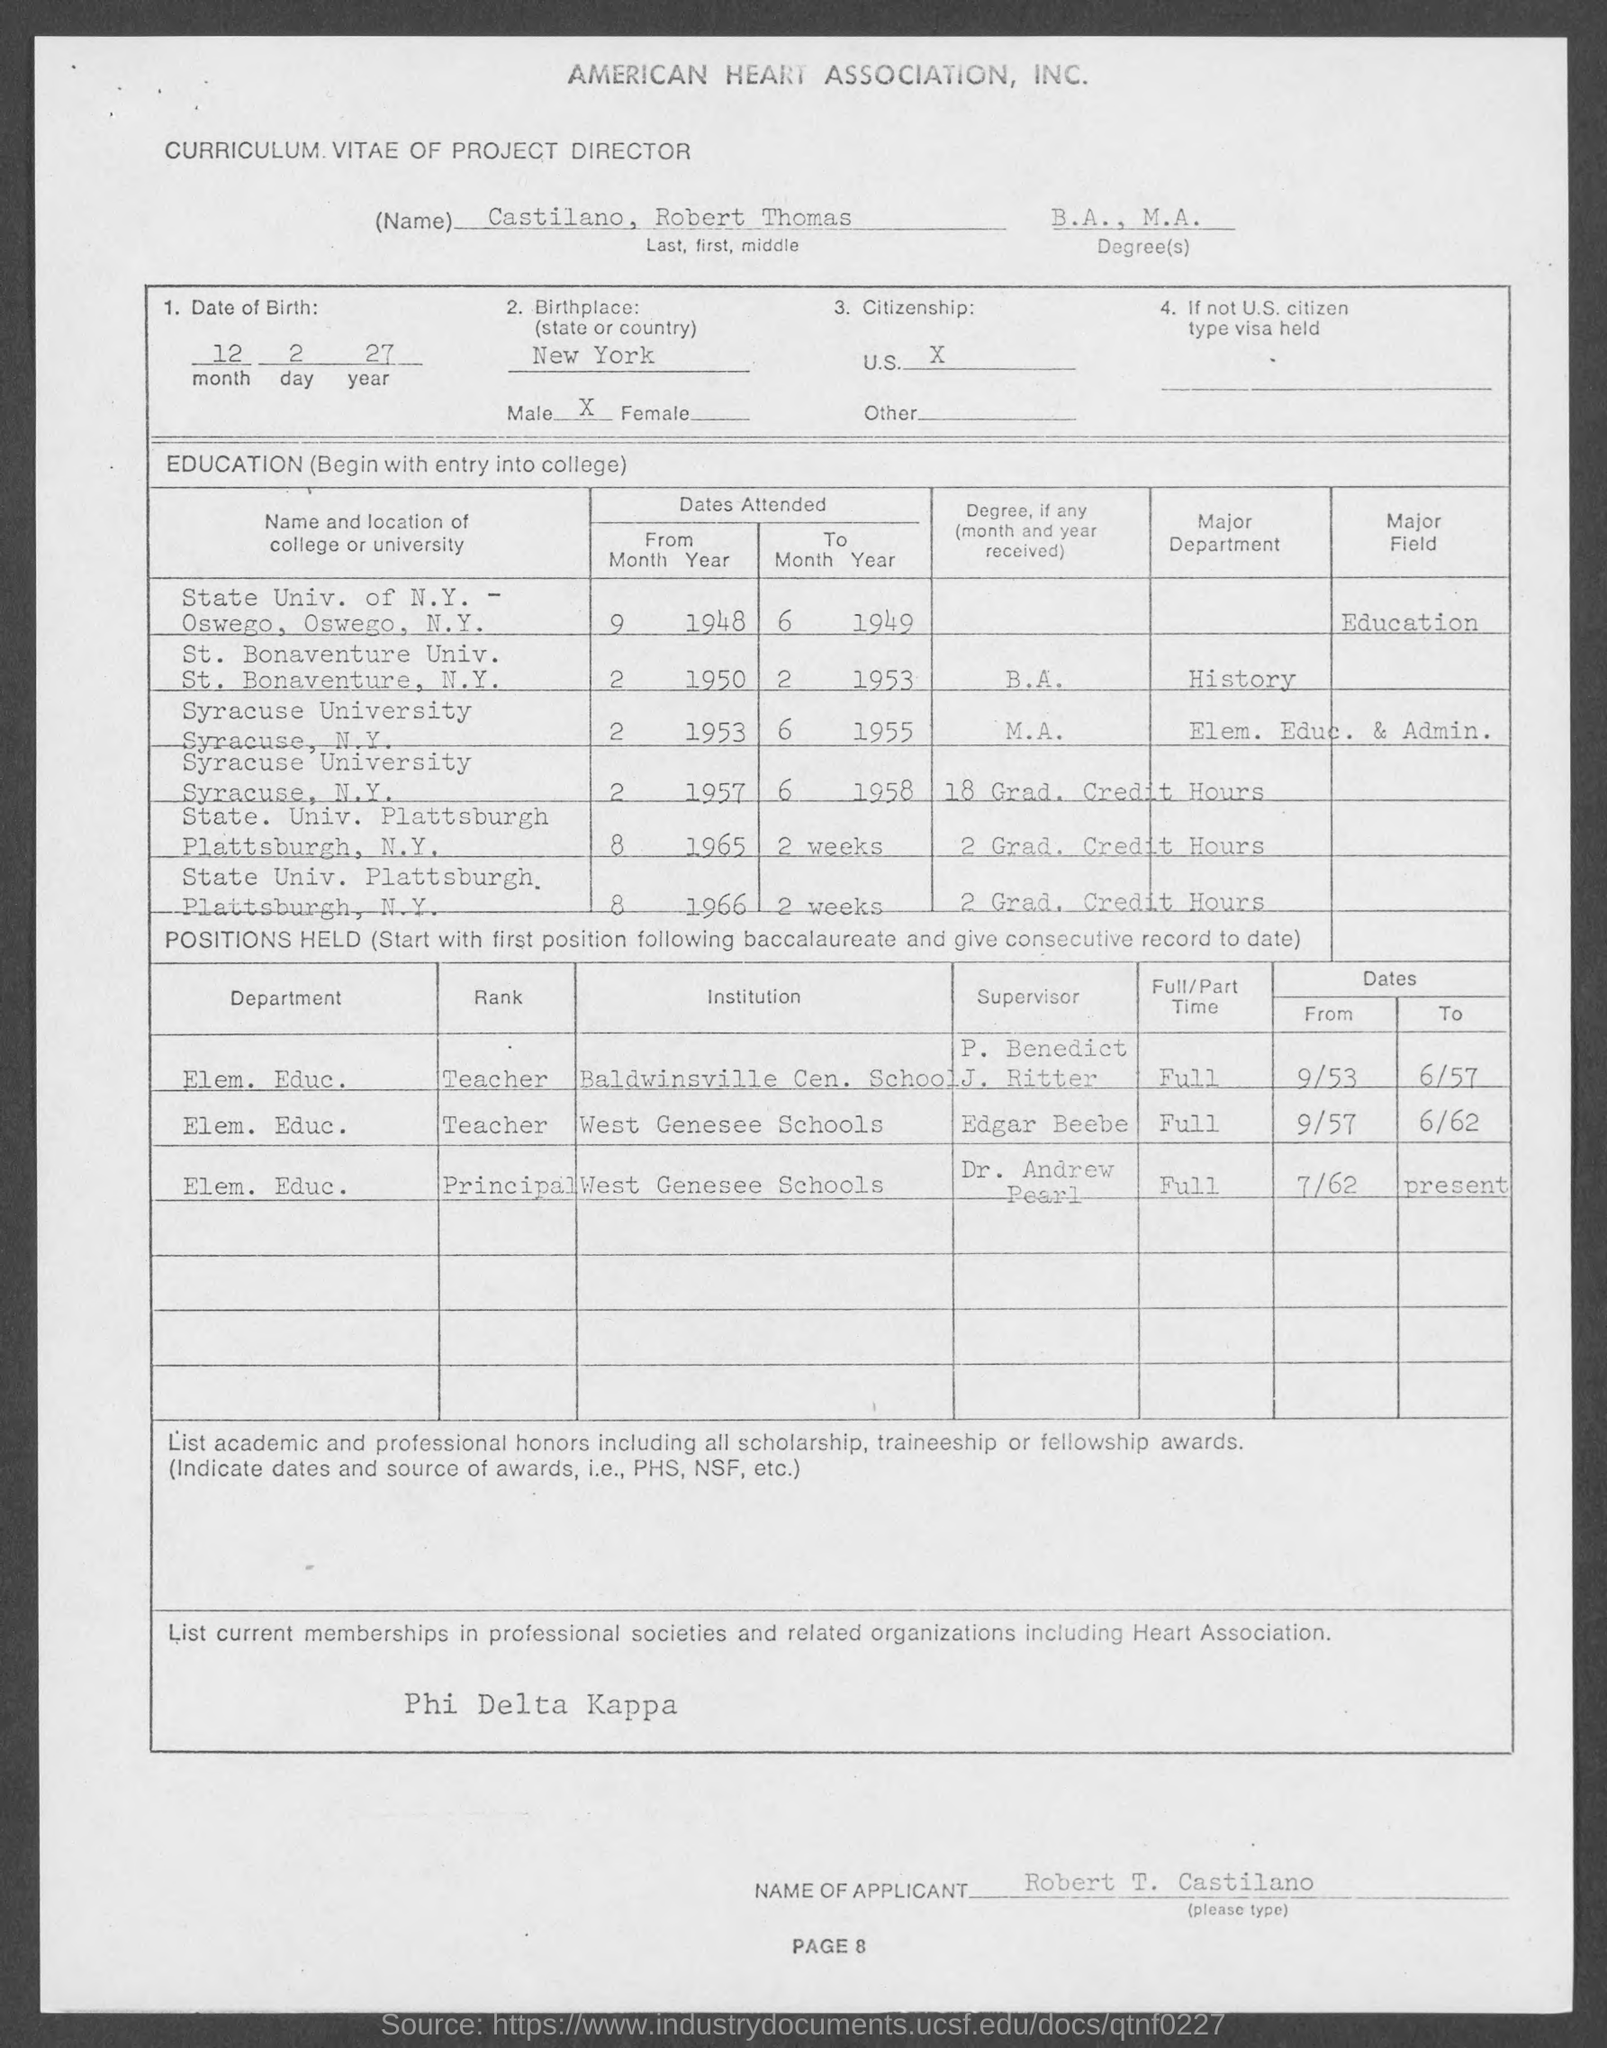What is the Title of the document?
Your answer should be compact. Curriculum Vitae of project Director. What is the Name?
Provide a succinct answer. Castilano, Robert Thomas. What are the Degrees?
Provide a succinct answer. B.A., M.A. What is the Date of Birth?
Offer a very short reply. 12 2 27. 